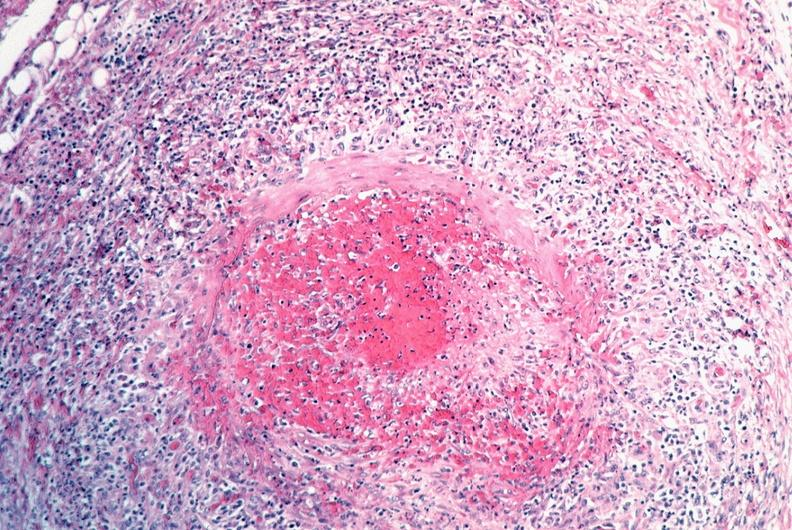what does this image show?
Answer the question using a single word or phrase. Vasculitis 